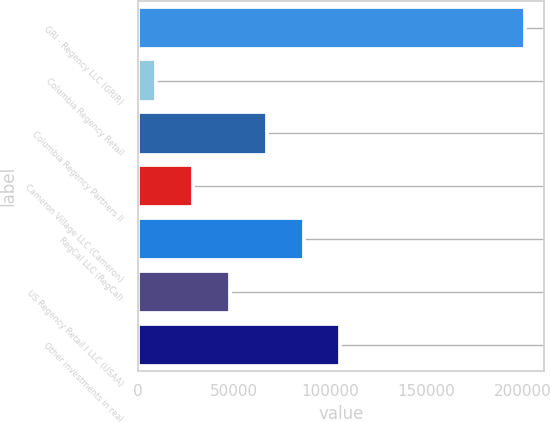Convert chart to OTSL. <chart><loc_0><loc_0><loc_500><loc_500><bar_chart><fcel>GRI - Regency LLC (GRIR)<fcel>Columbia Regency Retail<fcel>Columbia Regency Partners II<fcel>Cameron Village LLC (Cameron)<fcel>RegCal LLC (RegCal)<fcel>US Regency Retail I LLC (USAA)<fcel>Other investments in real<nl><fcel>201240<fcel>9687<fcel>67152.9<fcel>28842.3<fcel>86308.2<fcel>47997.6<fcel>105464<nl></chart> 